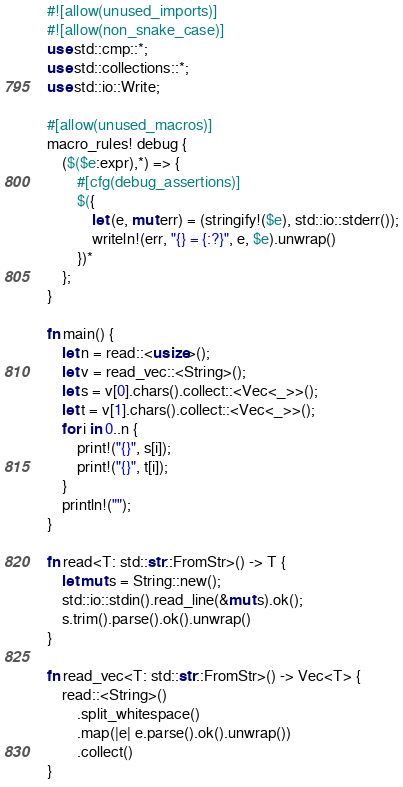<code> <loc_0><loc_0><loc_500><loc_500><_Rust_>#![allow(unused_imports)]
#![allow(non_snake_case)]
use std::cmp::*;
use std::collections::*;
use std::io::Write;

#[allow(unused_macros)]
macro_rules! debug {
    ($($e:expr),*) => {
        #[cfg(debug_assertions)]
        $({
            let (e, mut err) = (stringify!($e), std::io::stderr());
            writeln!(err, "{} = {:?}", e, $e).unwrap()
        })*
    };
}

fn main() {
    let n = read::<usize>();
    let v = read_vec::<String>();
    let s = v[0].chars().collect::<Vec<_>>();
    let t = v[1].chars().collect::<Vec<_>>();
    for i in 0..n {
        print!("{}", s[i]);
        print!("{}", t[i]);
    }
    println!("");
}

fn read<T: std::str::FromStr>() -> T {
    let mut s = String::new();
    std::io::stdin().read_line(&mut s).ok();
    s.trim().parse().ok().unwrap()
}

fn read_vec<T: std::str::FromStr>() -> Vec<T> {
    read::<String>()
        .split_whitespace()
        .map(|e| e.parse().ok().unwrap())
        .collect()
}
</code> 